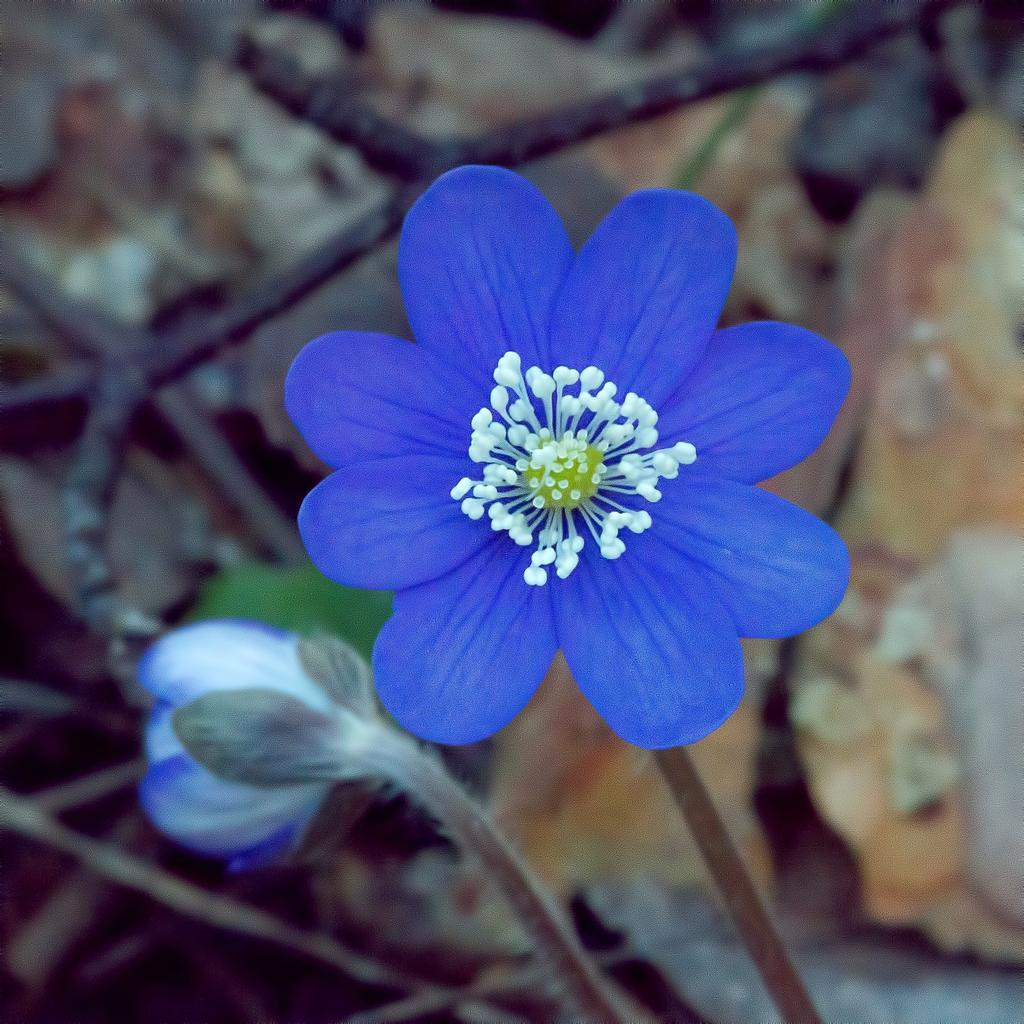What type of living organisms can be seen in the image? There are plants with flowers in the image. Can you describe the flowers on the plants? Unfortunately, the specific details of the flowers cannot be determined from the image alone. What might be the purpose of these plants with flowers? The purpose of these plants with flowers could be for decoration, food, or other purposes, but this cannot be determined from the image alone. What type of slave is depicted in the image? There is no depiction of a slave in the image; it features plants with flowers. What type of apple can be seen in the image? There is no apple present in the image; it features plants with flowers. 